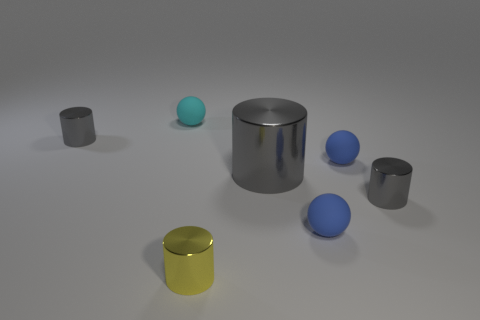Subtract all blue matte balls. How many balls are left? 1 How many gray cylinders must be subtracted to get 2 gray cylinders? 1 Subtract 4 cylinders. How many cylinders are left? 0 Subtract all yellow cylinders. Subtract all green blocks. How many cylinders are left? 3 Subtract all yellow blocks. How many yellow cylinders are left? 1 Subtract all big shiny cylinders. Subtract all yellow shiny objects. How many objects are left? 5 Add 6 cyan balls. How many cyan balls are left? 7 Add 6 gray cylinders. How many gray cylinders exist? 9 Add 3 yellow cylinders. How many objects exist? 10 Subtract all yellow cylinders. How many cylinders are left? 3 